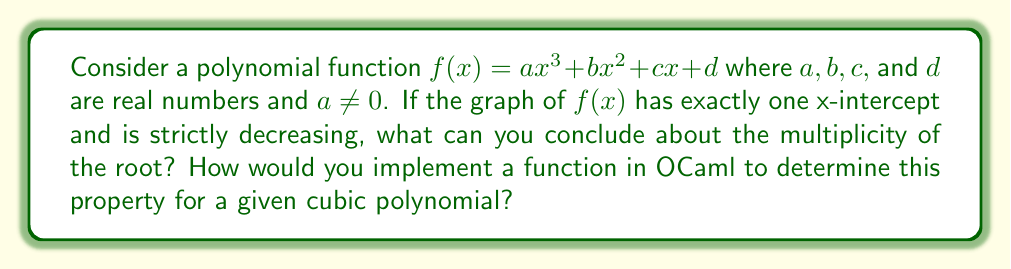Provide a solution to this math problem. Let's approach this step-by-step:

1) For a cubic function to have exactly one x-intercept, it must touch the x-axis at exactly one point. This means the root has a multiplicity of 3.

2) The multiplicity of a root affects the behavior of the function near that root:
   - If multiplicity is 1, the graph crosses the x-axis.
   - If multiplicity is 2, the graph touches the x-axis but doesn't cross it.
   - If multiplicity is 3, the graph crosses the x-axis, but changes direction immediately after.

3) Given that the function is strictly decreasing, this further confirms that the root has a multiplicity of 3. A cubic function with a triple root will have an inflection point at the root, changing from decreasing to increasing (or vice versa) at that point.

4) To implement this in OCaml, we can create a function that takes the coefficients of the cubic polynomial and checks two conditions:
   a) The discriminant of the cubic equation is zero (indicating a triple root)
   b) The derivative of the function is always negative (indicating strictly decreasing)

5) The discriminant of a cubic equation $ax^3 + bx^2 + cx + d = 0$ is given by:

   $$\Delta = 18abcd - 4b^3d + b^2c^2 - 4ac^3 - 27a^2d^2$$

6) The derivative of the cubic function is:

   $$f'(x) = 3ax^2 + 2bx + c$$

7) For the function to be strictly decreasing, we need $f'(x) < 0$ for all x, which means:
   - The leading coefficient (3a) must be negative
   - The discriminant of $f'(x)$ must be less than or equal to zero

Here's a possible OCaml implementation:

```ocaml
let has_triple_root_and_decreasing a b c d =
  let discriminant = 18.*.a*.b*.c*.d -. 4.*.b**3.*.d +. b**2.*.c**2. -. 4.*.a*.c**3. -. 27.*.a**2.*.d**2. in
  let derivative_discriminant = 4.*.b**2. -. 12.*.a*.c in
  abs discriminant < 1e-10 && a < 0. && derivative_discriminant <= 0.
```

This function returns true if the cubic polynomial has a triple root and is strictly decreasing, and false otherwise.
Answer: The root has multiplicity 3. 